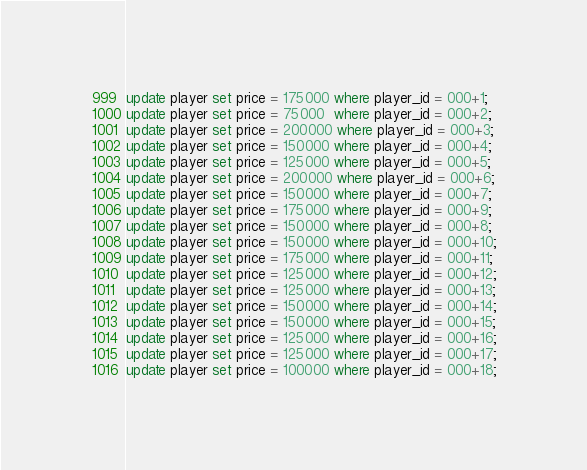<code> <loc_0><loc_0><loc_500><loc_500><_SQL_>update player set price = 175000 where player_id = 000+1;
update player set price = 75000  where player_id = 000+2;
update player set price = 200000 where player_id = 000+3;
update player set price = 150000 where player_id = 000+4;
update player set price = 125000 where player_id = 000+5;
update player set price = 200000 where player_id = 000+6;
update player set price = 150000 where player_id = 000+7;
update player set price = 175000 where player_id = 000+9;
update player set price = 150000 where player_id = 000+8;
update player set price = 150000 where player_id = 000+10;
update player set price = 175000 where player_id = 000+11;
update player set price = 125000 where player_id = 000+12;
update player set price = 125000 where player_id = 000+13;
update player set price = 150000 where player_id = 000+14;
update player set price = 150000 where player_id = 000+15;
update player set price = 125000 where player_id = 000+16;
update player set price = 125000 where player_id = 000+17;
update player set price = 100000 where player_id = 000+18;</code> 